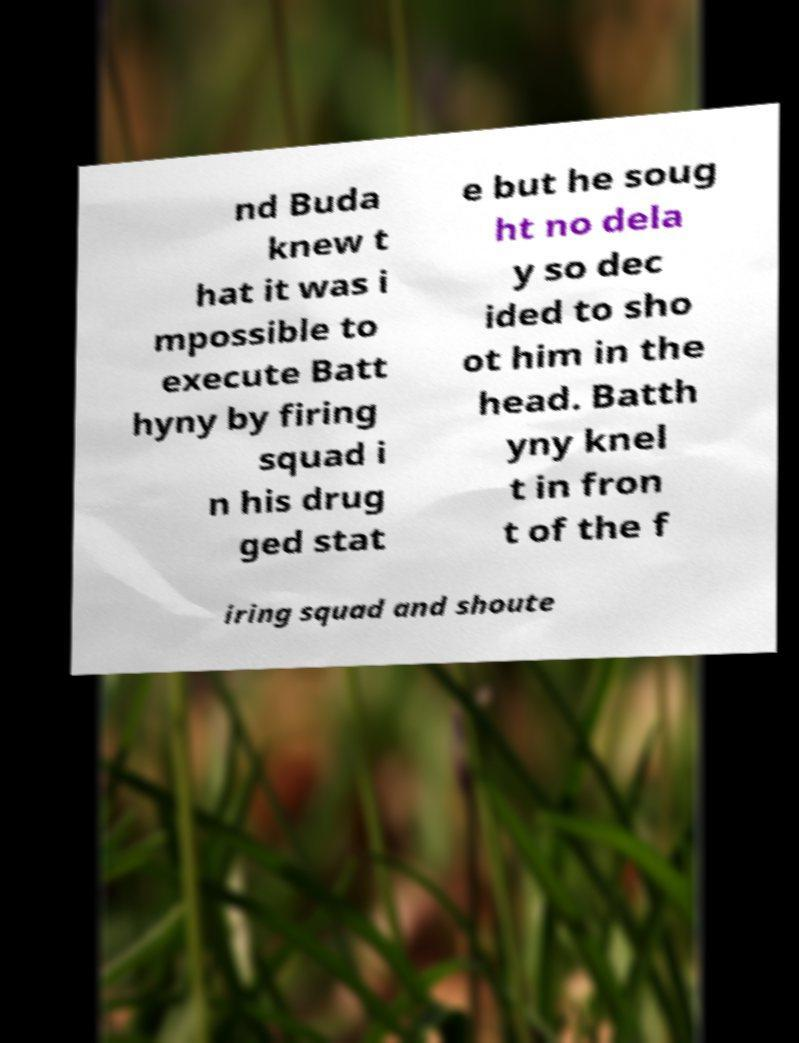Can you read and provide the text displayed in the image?This photo seems to have some interesting text. Can you extract and type it out for me? nd Buda knew t hat it was i mpossible to execute Batt hyny by firing squad i n his drug ged stat e but he soug ht no dela y so dec ided to sho ot him in the head. Batth yny knel t in fron t of the f iring squad and shoute 